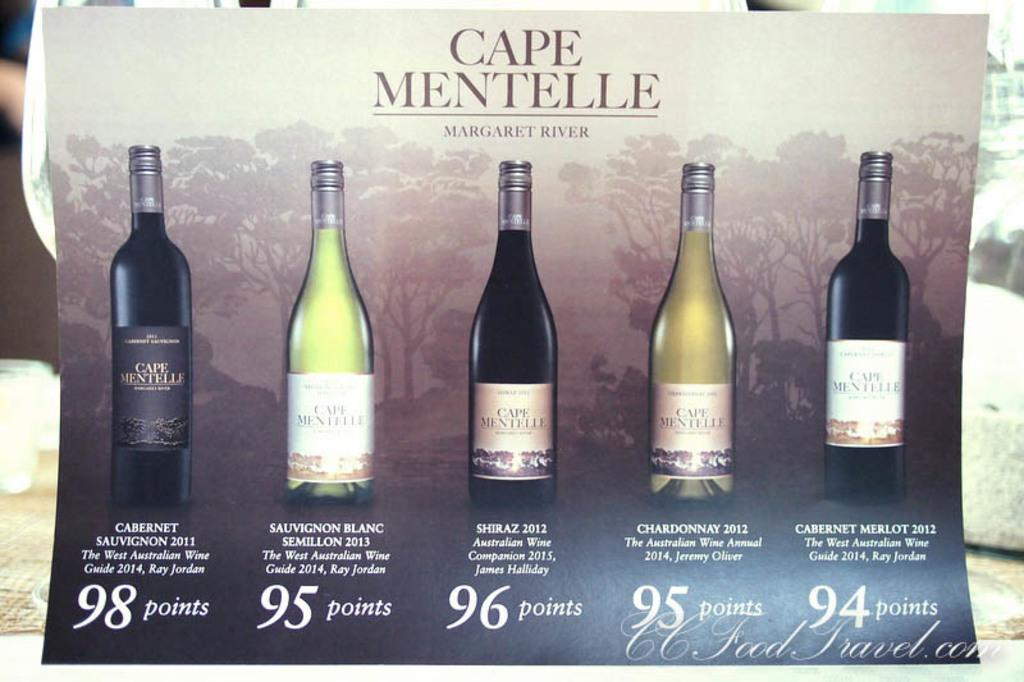Provide a one-sentence caption for the provided image. Several bottles of Cape Mentelle wine are lined up on this poster. 